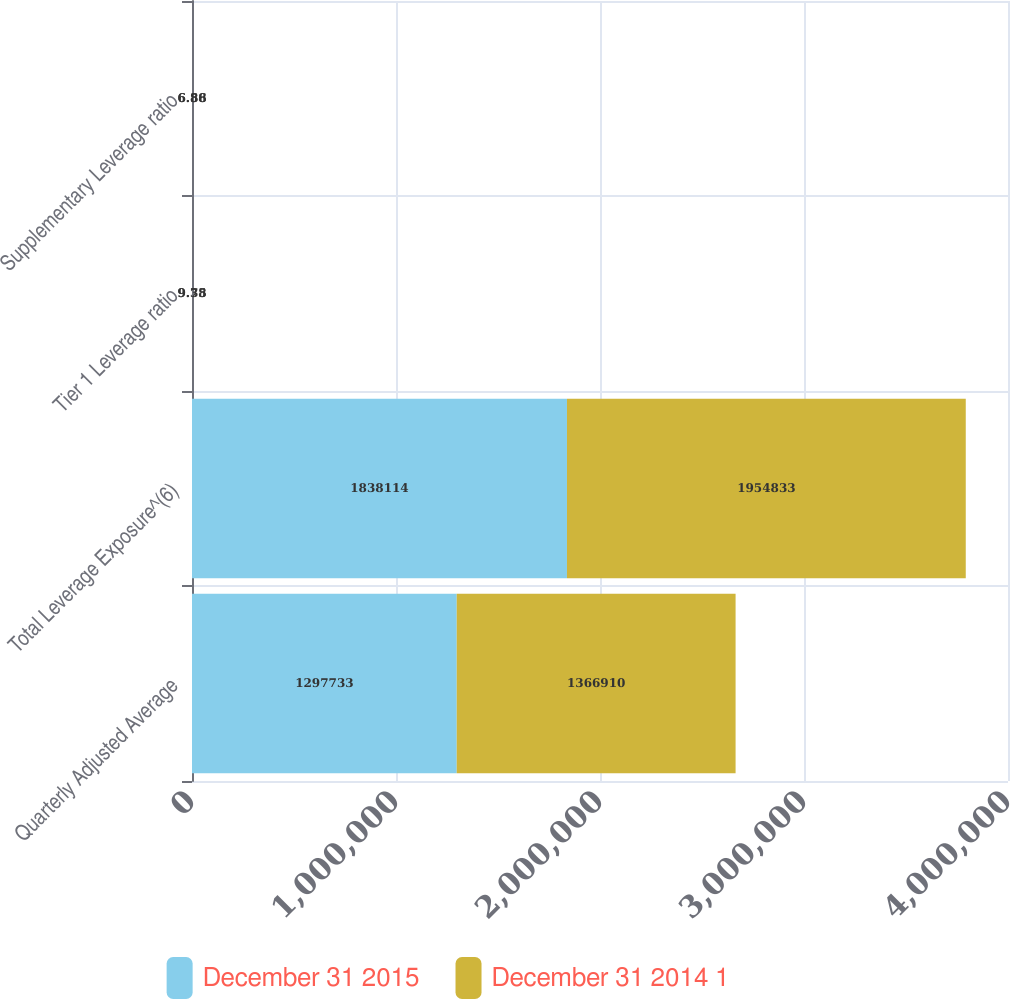Convert chart to OTSL. <chart><loc_0><loc_0><loc_500><loc_500><stacked_bar_chart><ecel><fcel>Quarterly Adjusted Average<fcel>Total Leverage Exposure^(6)<fcel>Tier 1 Leverage ratio<fcel>Supplementary Leverage ratio<nl><fcel>December 31 2015<fcel>1.29773e+06<fcel>1.83811e+06<fcel>9.75<fcel>6.88<nl><fcel>December 31 2014 1<fcel>1.36691e+06<fcel>1.95483e+06<fcel>9.38<fcel>6.56<nl></chart> 